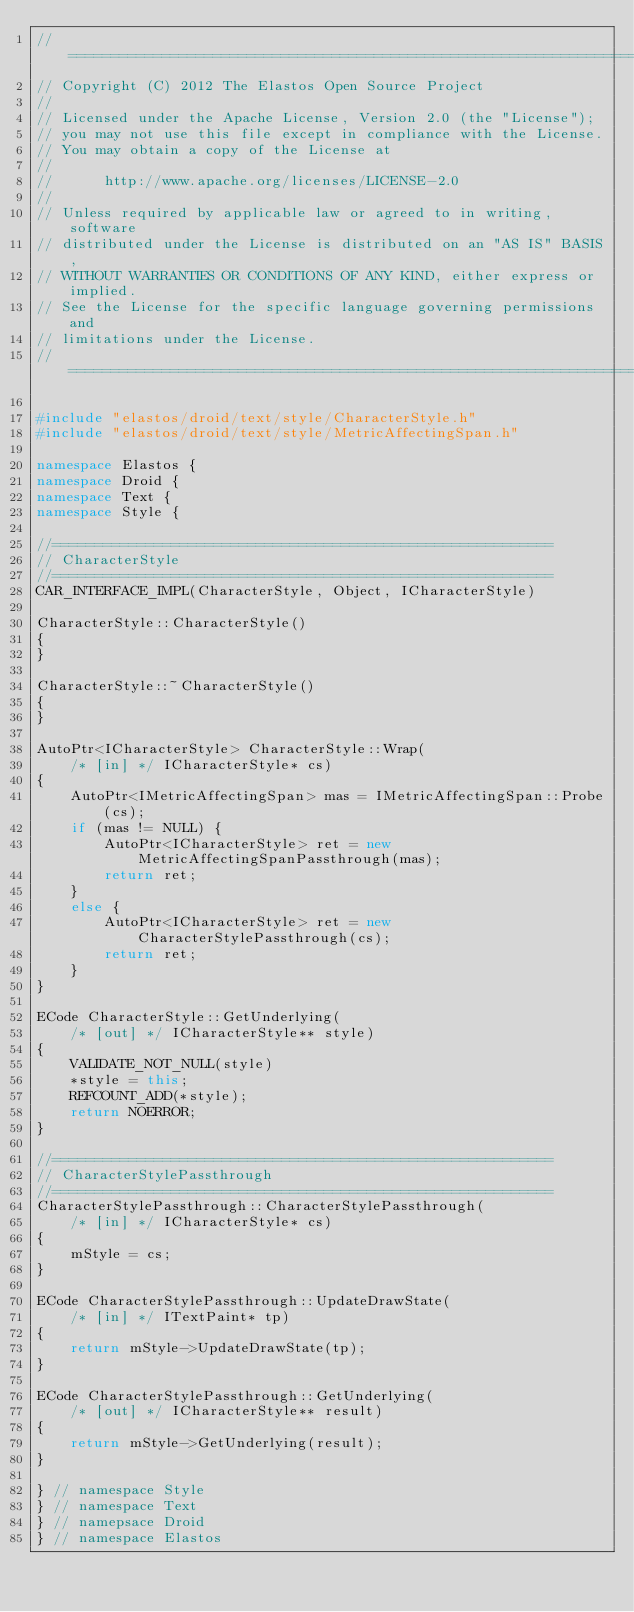<code> <loc_0><loc_0><loc_500><loc_500><_C++_>//=========================================================================
// Copyright (C) 2012 The Elastos Open Source Project
//
// Licensed under the Apache License, Version 2.0 (the "License");
// you may not use this file except in compliance with the License.
// You may obtain a copy of the License at
//
//      http://www.apache.org/licenses/LICENSE-2.0
//
// Unless required by applicable law or agreed to in writing, software
// distributed under the License is distributed on an "AS IS" BASIS,
// WITHOUT WARRANTIES OR CONDITIONS OF ANY KIND, either express or implied.
// See the License for the specific language governing permissions and
// limitations under the License.
//=========================================================================

#include "elastos/droid/text/style/CharacterStyle.h"
#include "elastos/droid/text/style/MetricAffectingSpan.h"

namespace Elastos {
namespace Droid {
namespace Text {
namespace Style {

//===========================================================
// CharacterStyle
//===========================================================
CAR_INTERFACE_IMPL(CharacterStyle, Object, ICharacterStyle)

CharacterStyle::CharacterStyle()
{
}

CharacterStyle::~CharacterStyle()
{
}

AutoPtr<ICharacterStyle> CharacterStyle::Wrap(
    /* [in] */ ICharacterStyle* cs)
{
    AutoPtr<IMetricAffectingSpan> mas = IMetricAffectingSpan::Probe(cs);
    if (mas != NULL) {
        AutoPtr<ICharacterStyle> ret = new MetricAffectingSpanPassthrough(mas);
        return ret;
    }
    else {
        AutoPtr<ICharacterStyle> ret = new CharacterStylePassthrough(cs);
        return ret;
    }
}

ECode CharacterStyle::GetUnderlying(
    /* [out] */ ICharacterStyle** style)
{
    VALIDATE_NOT_NULL(style)
    *style = this;
    REFCOUNT_ADD(*style);
    return NOERROR;
}

//===========================================================
// CharacterStylePassthrough
//===========================================================
CharacterStylePassthrough::CharacterStylePassthrough(
    /* [in] */ ICharacterStyle* cs)
{
    mStyle = cs;
}

ECode CharacterStylePassthrough::UpdateDrawState(
    /* [in] */ ITextPaint* tp)
{
    return mStyle->UpdateDrawState(tp);
}

ECode CharacterStylePassthrough::GetUnderlying(
    /* [out] */ ICharacterStyle** result)
{
    return mStyle->GetUnderlying(result);
}

} // namespace Style
} // namespace Text
} // namepsace Droid
} // namespace Elastos</code> 